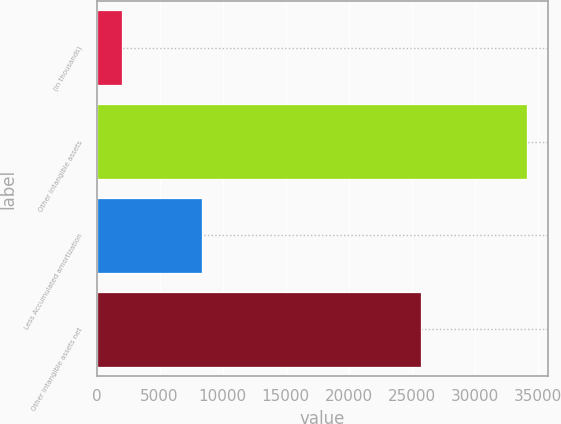<chart> <loc_0><loc_0><loc_500><loc_500><bar_chart><fcel>(in thousands)<fcel>Other intangible assets<fcel>Less Accumulated amortization<fcel>Other intangible assets net<nl><fcel>2008<fcel>34121<fcel>8402<fcel>25719<nl></chart> 